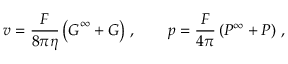Convert formula to latex. <formula><loc_0><loc_0><loc_500><loc_500>v = \frac { F } { 8 \pi \eta } \left ( G ^ { \infty } + G \right ) \, , \quad p = \frac { F } { 4 \pi } \left ( P ^ { \infty } + P \right ) \, ,</formula> 